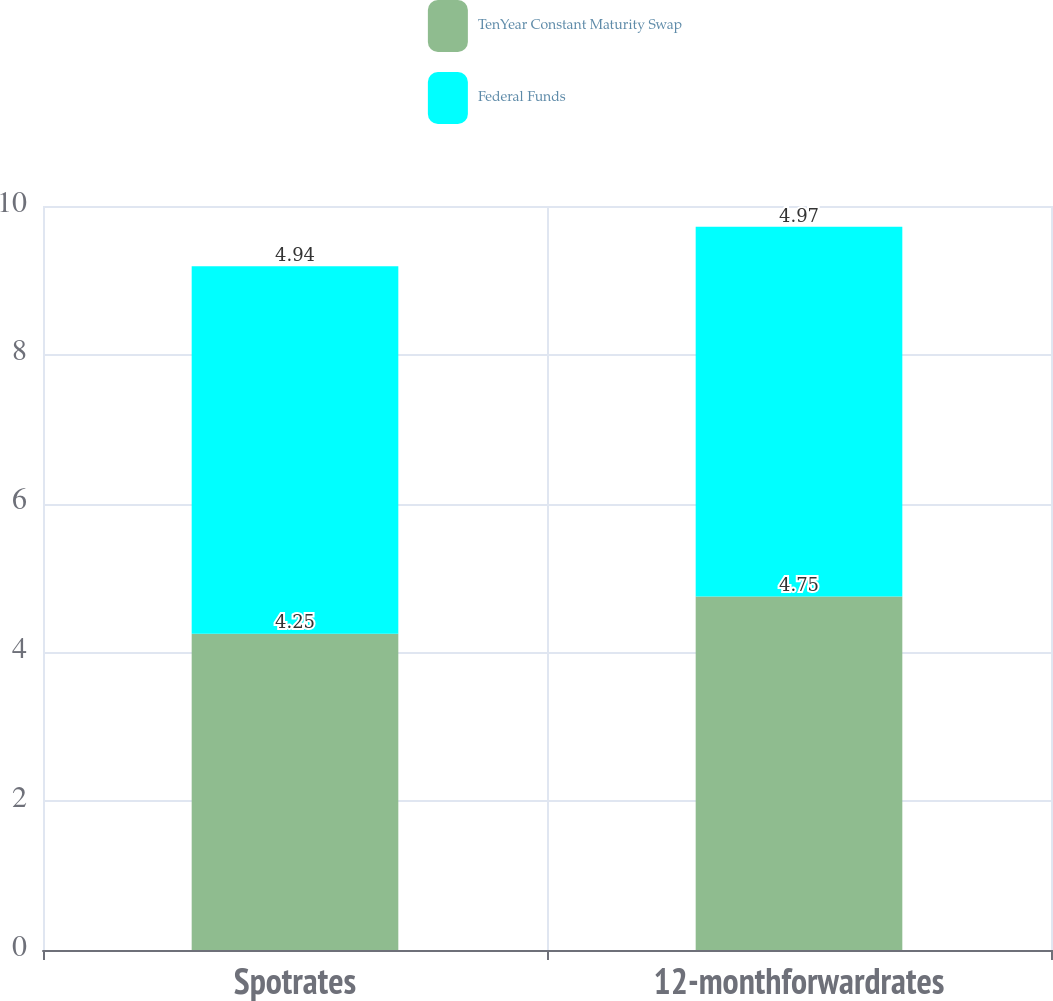Convert chart. <chart><loc_0><loc_0><loc_500><loc_500><stacked_bar_chart><ecel><fcel>Spotrates<fcel>12-monthforwardrates<nl><fcel>TenYear Constant Maturity Swap<fcel>4.25<fcel>4.75<nl><fcel>Federal Funds<fcel>4.94<fcel>4.97<nl></chart> 